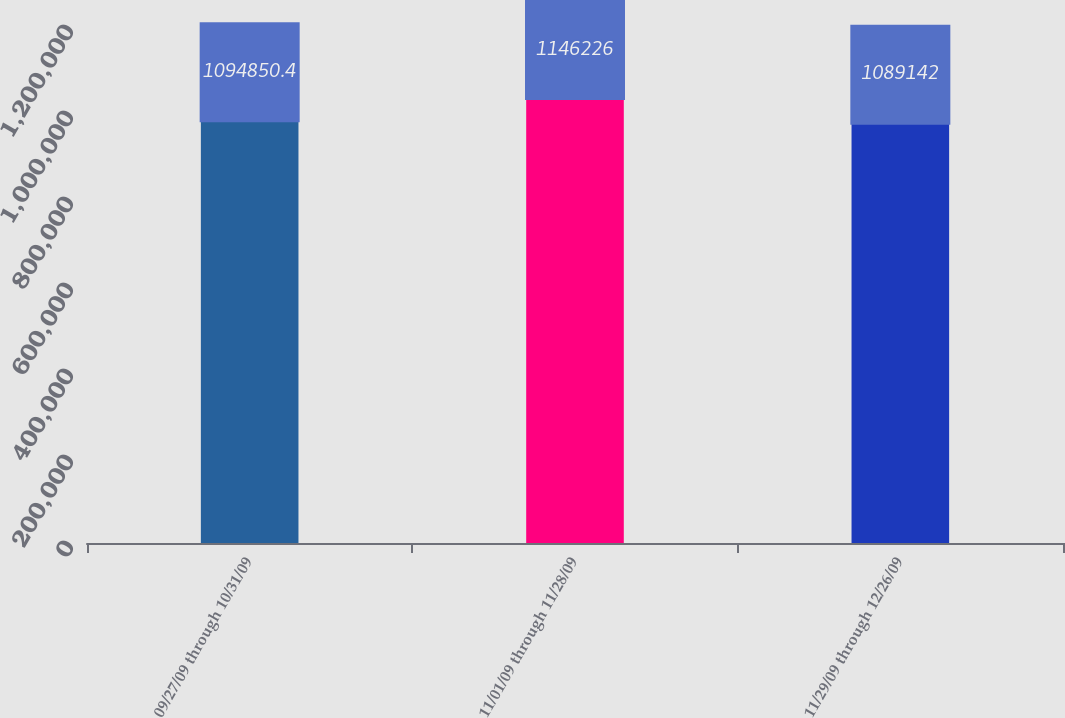Convert chart. <chart><loc_0><loc_0><loc_500><loc_500><bar_chart><fcel>09/27/09 through 10/31/09<fcel>11/01/09 through 11/28/09<fcel>11/29/09 through 12/26/09<nl><fcel>1.09485e+06<fcel>1.14623e+06<fcel>1.08914e+06<nl></chart> 